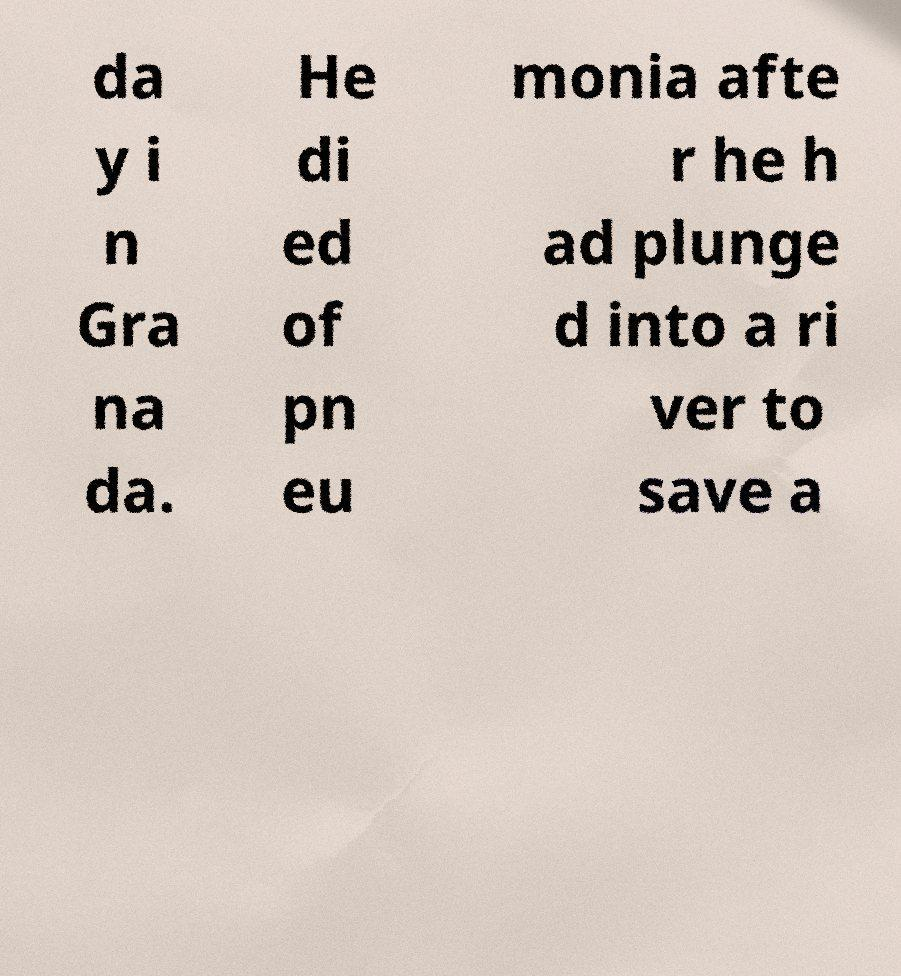Please identify and transcribe the text found in this image. da y i n Gra na da. He di ed of pn eu monia afte r he h ad plunge d into a ri ver to save a 